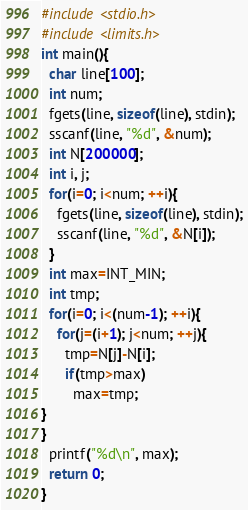Convert code to text. <code><loc_0><loc_0><loc_500><loc_500><_C_>#include <stdio.h>
#include <limits.h>
int main(){
  char line[100];
  int num;
  fgets(line, sizeof(line), stdin);
  sscanf(line, "%d", &num);
  int N[200000];
  int i, j;
  for(i=0; i<num; ++i){
	fgets(line, sizeof(line), stdin);
	sscanf(line, "%d", &N[i]);
  }
  int max=INT_MIN;
  int tmp;
  for(i=0; i<(num-1); ++i){
	for(j=(i+1); j<num; ++j){
	  tmp=N[j]-N[i];
	  if(tmp>max)
		max=tmp;
}
}
  printf("%d\n", max);
  return 0;
}

</code> 